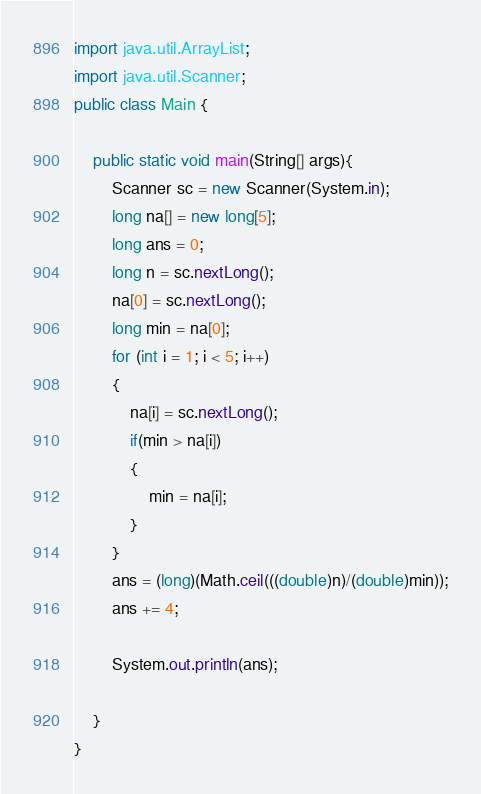Convert code to text. <code><loc_0><loc_0><loc_500><loc_500><_Java_>import java.util.ArrayList;
import java.util.Scanner;
public class Main {
	
	public static void main(String[] args){
		Scanner sc = new Scanner(System.in);
		long na[] = new long[5];
		long ans = 0;
		long n = sc.nextLong();
		na[0] = sc.nextLong();
		long min = na[0];
		for (int i = 1; i < 5; i++)
		{
			na[i] = sc.nextLong();
			if(min > na[i])
			{
				min = na[i];
			}
		}
		ans = (long)(Math.ceil(((double)n)/(double)min));
		ans += 4;

		System.out.println(ans);

	}
}</code> 